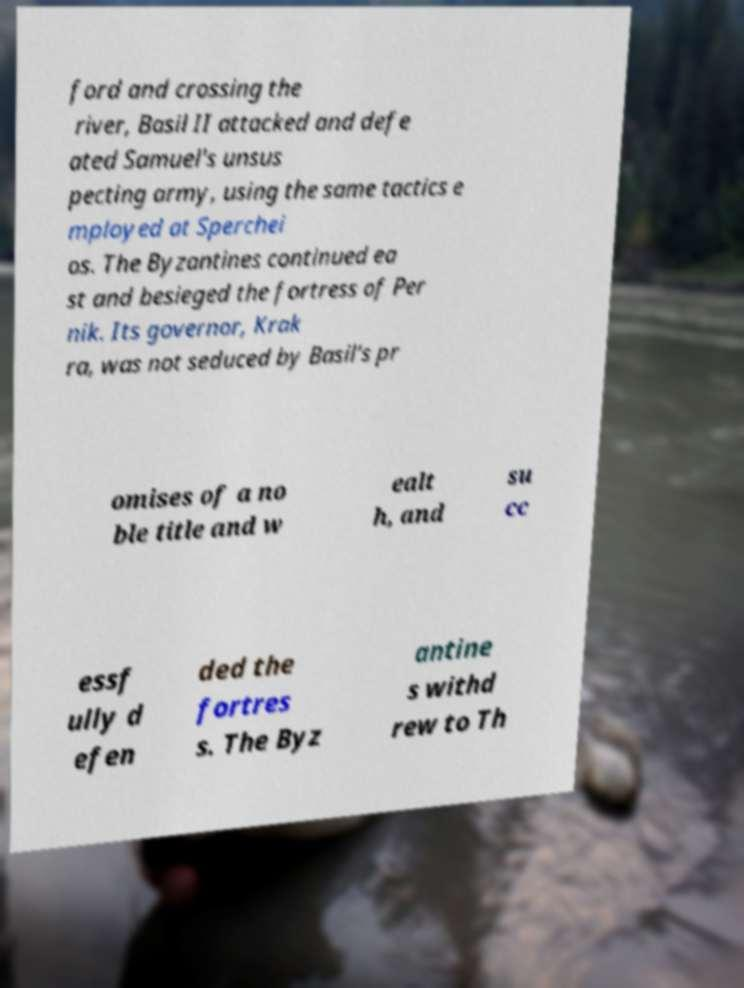What messages or text are displayed in this image? I need them in a readable, typed format. ford and crossing the river, Basil II attacked and defe ated Samuel's unsus pecting army, using the same tactics e mployed at Sperchei os. The Byzantines continued ea st and besieged the fortress of Per nik. Its governor, Krak ra, was not seduced by Basil's pr omises of a no ble title and w ealt h, and su cc essf ully d efen ded the fortres s. The Byz antine s withd rew to Th 